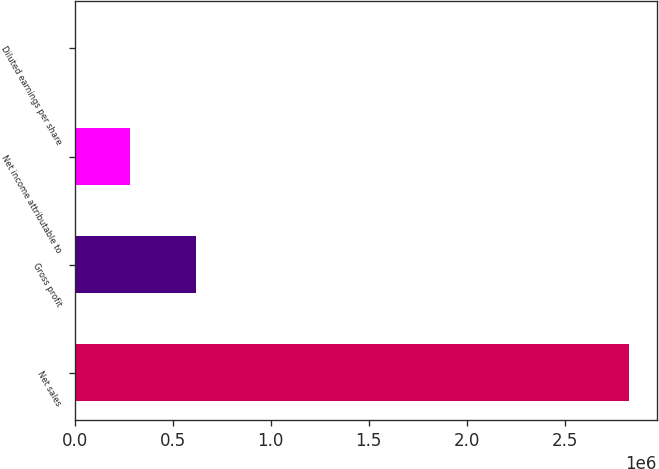Convert chart. <chart><loc_0><loc_0><loc_500><loc_500><bar_chart><fcel>Net sales<fcel>Gross profit<fcel>Net income attributable to<fcel>Diluted earnings per share<nl><fcel>2.82866e+06<fcel>619264<fcel>282868<fcel>1.37<nl></chart> 